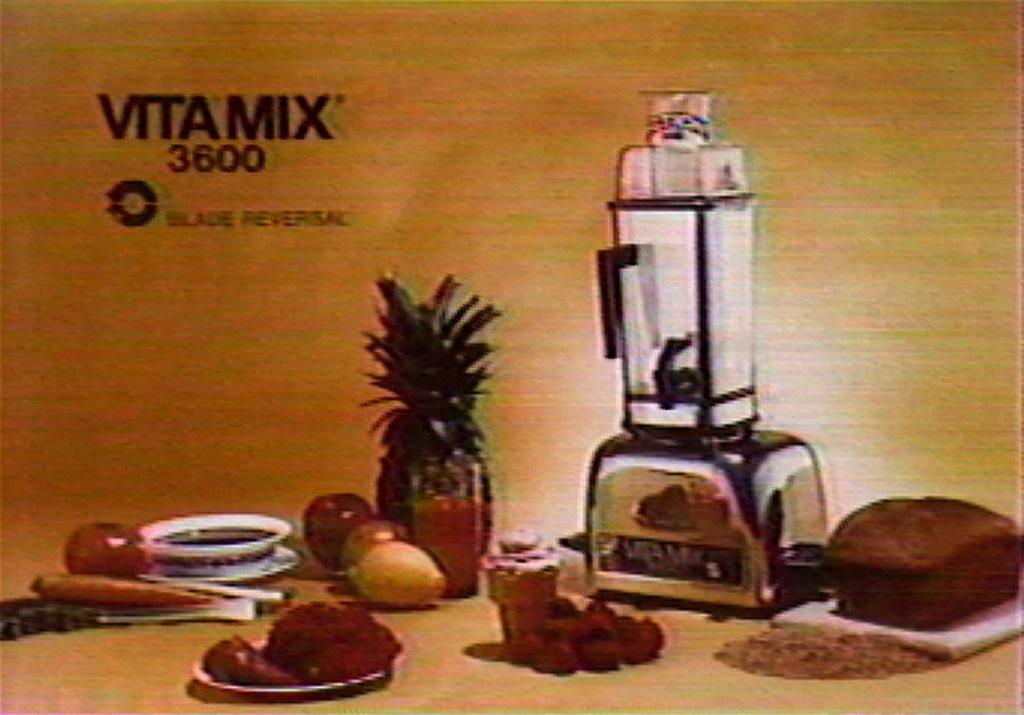<image>
Create a compact narrative representing the image presented. An advertisement for the Vitamix 3600 which states "Blade Reversal" 